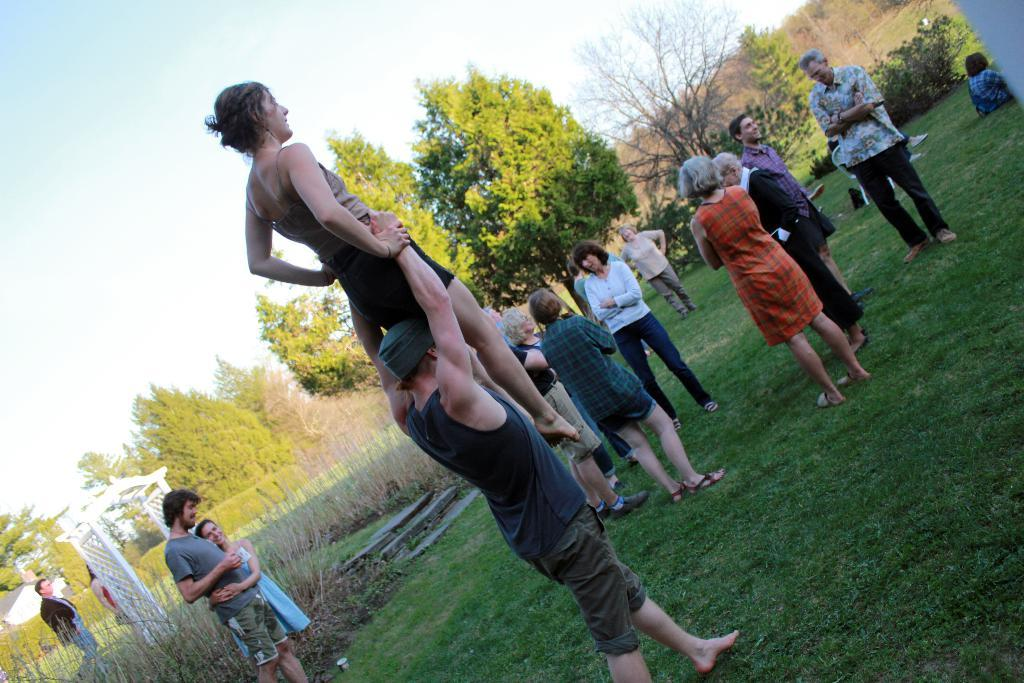Where was the image taken? The image was clicked outside. What can be seen in the middle of the image? There are trees and some persons in the middle of the image. What is visible at the top of the image? The sky is visible at the top of the image. What type of frame is used to hold the trees in the image? There is no frame present in the image; the trees are not held by any frame. In which direction are the persons walking in the image? The image does not show any persons walking; they are standing in the middle of the image. 